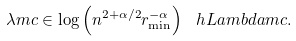Convert formula to latex. <formula><loc_0><loc_0><loc_500><loc_500>\lambda m c \in \log \left ( n ^ { 2 + \alpha / 2 } r _ { \min } ^ { - \alpha } \right ) \ h L a m b d a m c .</formula> 